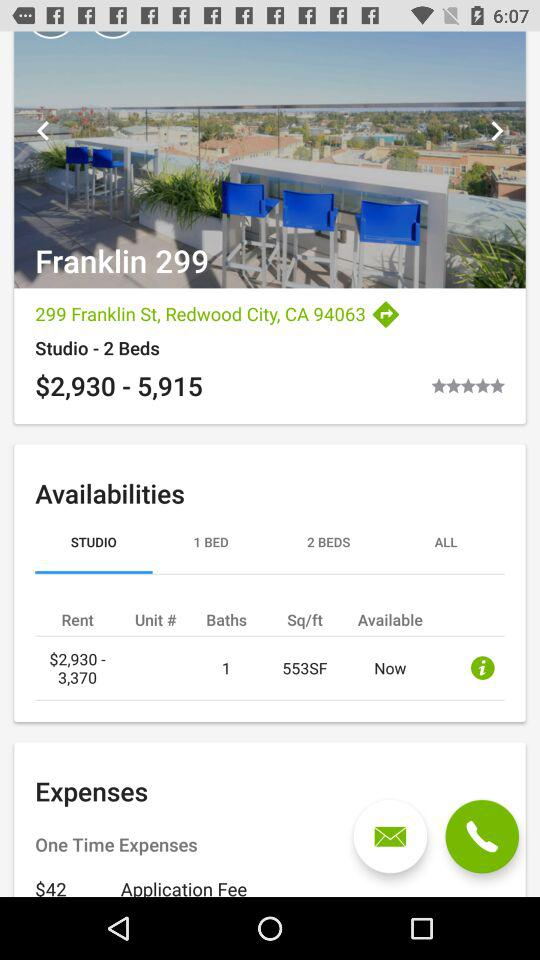How many beds are available?
Answer the question using a single word or phrase. 2 